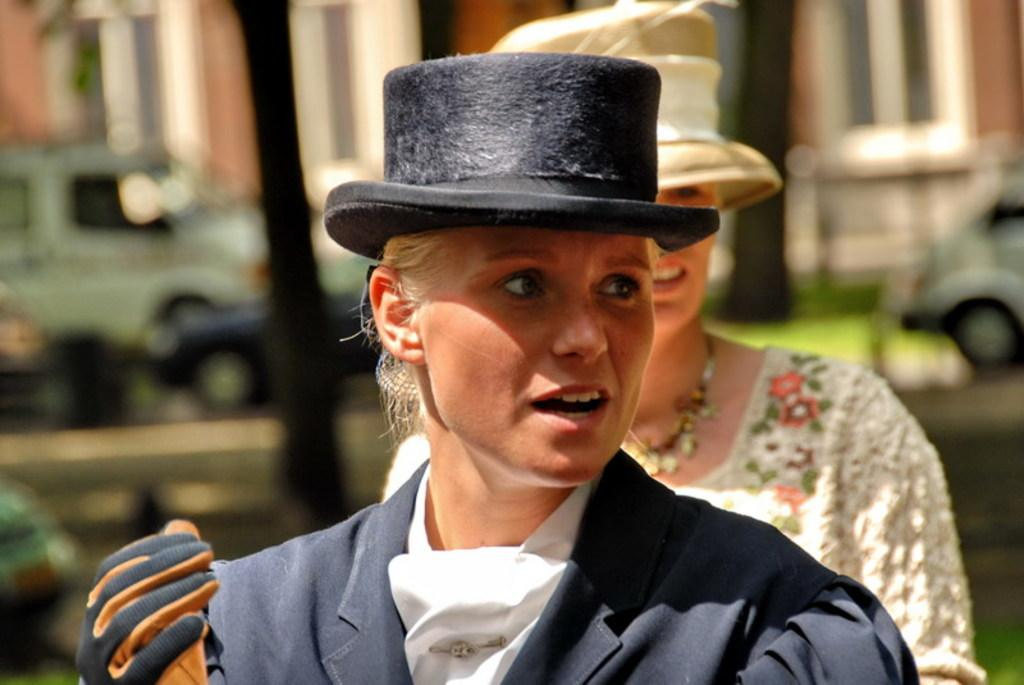How many women are in the image? There are two women in the image. What is one of the women wearing? One of the women is wearing a coat. What type of accessory is the woman wearing on her hands? The woman is wearing gloves. What type of headwear is the woman wearing? The woman is wearing a black color hat on her head. What can be seen in the background of the image? There are vehicles and at least one building in the background of the image. What is causing the woman's throat to feel sore in the image? There is no indication in the image that the woman's throat is sore or that there is any cause for it. 